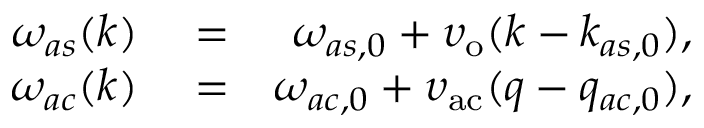Convert formula to latex. <formula><loc_0><loc_0><loc_500><loc_500>\begin{array} { r l r } { \omega _ { a s } ( k ) } & = } & { \omega _ { a s , 0 } + \upsilon _ { o } ( k - k _ { a s , 0 } ) , } \\ { \omega _ { a c } ( k ) } & = } & { \omega _ { a c , 0 } + \upsilon _ { a c } ( q - q _ { a c , 0 } ) , } \end{array}</formula> 